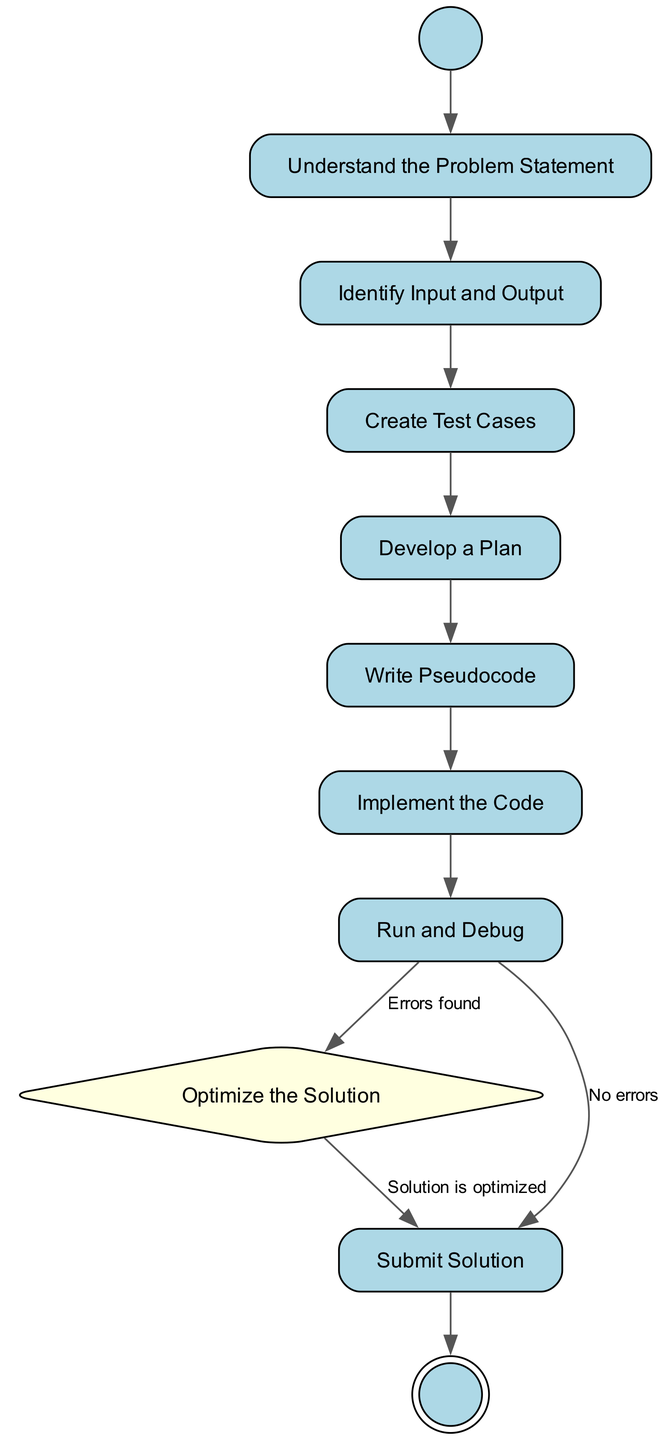What is the first step in solving a coding problem? The first step in the activity diagram is "Understand the Problem Statement". This is indicated by the first action after the start node.
Answer: Understand the Problem Statement How many total actions are there in the diagram? There are eight actions listed in the steps section of the diagram.
Answer: Eight Which step follows "Create Test Cases"? The step that follows "Create Test Cases" is "Develop a Plan". This follows directly in the transition sequence established in the diagram.
Answer: Develop a Plan What decision must be made after "Run and Debug"? The decision made after "Run and Debug" is "Optimize the Solution". This indicates a conditional path where the process can either lead to optimization or submission depending on the presence of errors.
Answer: Optimize the Solution What is the condition for moving from "Run and Debug" to "Submit Solution"? The condition for transitioning from "Run and Debug" to "Submit Solution" is "No errors". This implies that if there are no errors found during debugging, the solution can be submitted directly.
Answer: No errors What type of diagram is represented here? The diagram represents an "Activity Diagram". This type designed to illustrate the workflow and activities involved in solving a coding problem in a structured manner.
Answer: Activity Diagram What is the last action before submission of the solution? The last action before submitting the solution is "Optimize the Solution". This step is crucial for ensuring the efficiency of the final solution before it is submitted.
Answer: Optimize the Solution How many edges connect the steps that lead to submission? There are three edges that connect the steps leading to submission: one from "Run and Debug" with "No errors", one from "Optimize the Solution" with "Solution is optimized", and the direct connection from the last action to the end node.
Answer: Three What is the shape of the node representing a decision in the diagram? The shape of the node representing a decision in the diagram is a "diamond". This specific shape is used to indicate branching logic based on conditions.
Answer: Diamond 